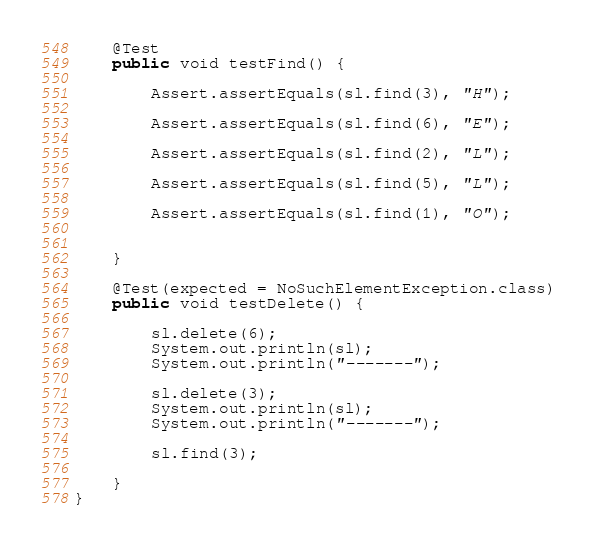<code> <loc_0><loc_0><loc_500><loc_500><_Java_>    @Test
    public void testFind() {

        Assert.assertEquals(sl.find(3), "H");

        Assert.assertEquals(sl.find(6), "E");

        Assert.assertEquals(sl.find(2), "L");

        Assert.assertEquals(sl.find(5), "L");

        Assert.assertEquals(sl.find(1), "O");


    }

    @Test(expected = NoSuchElementException.class)
    public void testDelete() {

        sl.delete(6);
        System.out.println(sl);
        System.out.println("-------");

        sl.delete(3);
        System.out.println(sl);
        System.out.println("-------");

        sl.find(3);

    }
}
</code> 